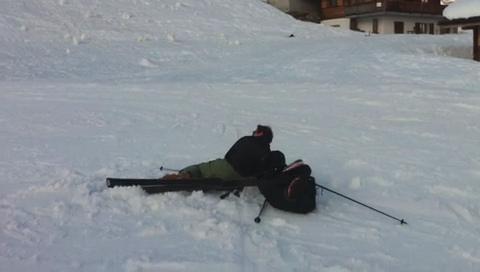How many people are there?
Give a very brief answer. 2. How many people are visible?
Give a very brief answer. 2. How many black horse are there in the image ?
Give a very brief answer. 0. 